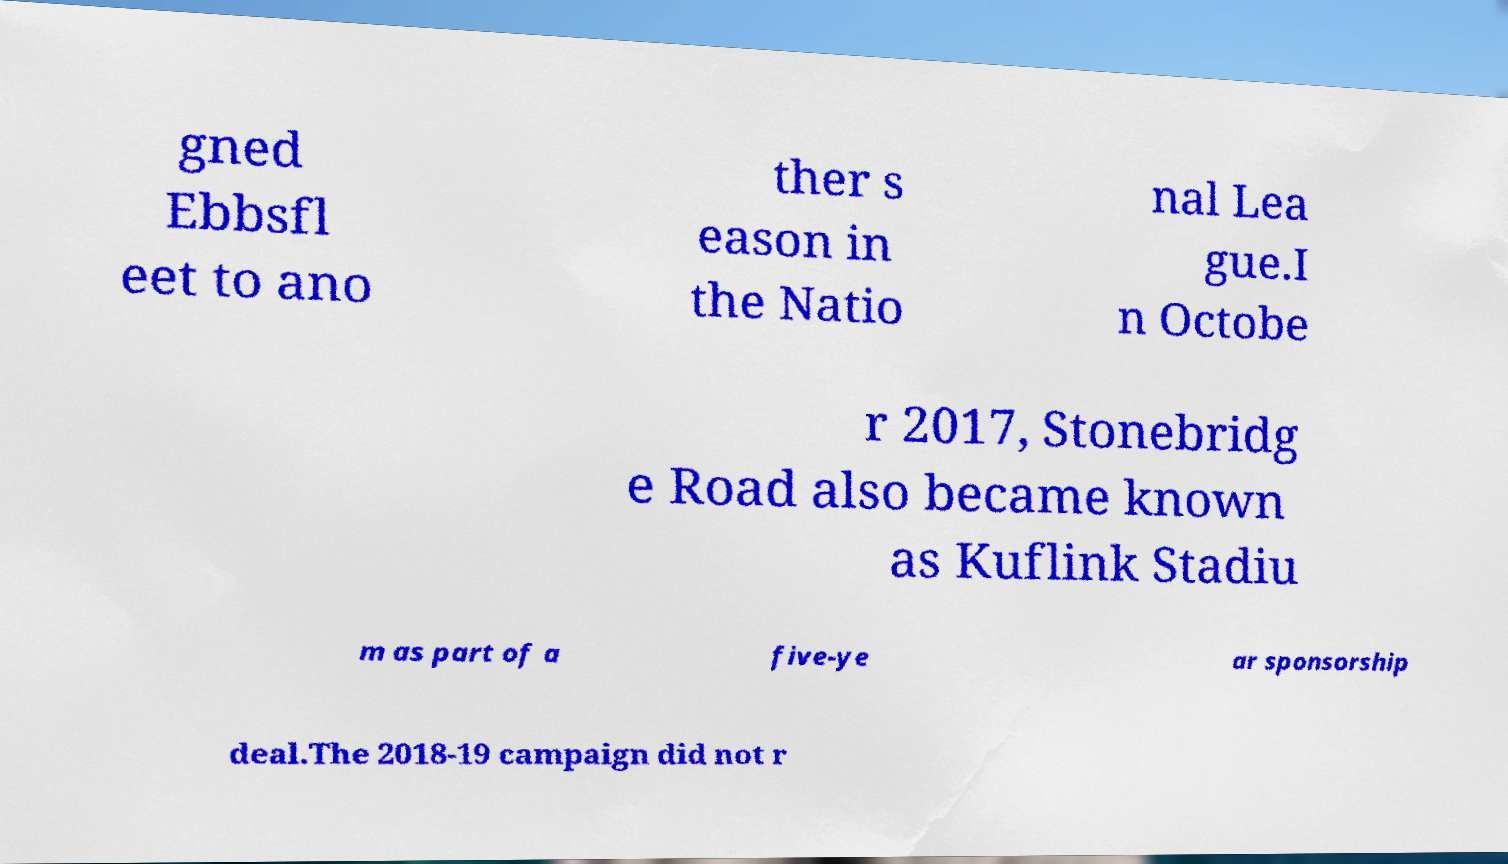There's text embedded in this image that I need extracted. Can you transcribe it verbatim? gned Ebbsfl eet to ano ther s eason in the Natio nal Lea gue.I n Octobe r 2017, Stonebridg e Road also became known as Kuflink Stadiu m as part of a five-ye ar sponsorship deal.The 2018-19 campaign did not r 